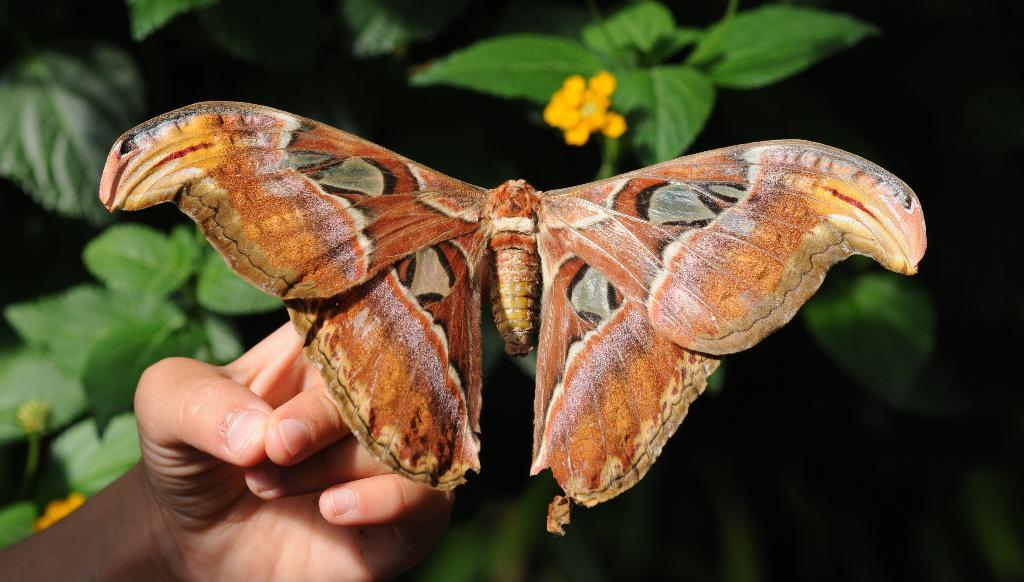What is the main subject of the image? The main subject of the image is a butterfly. Where is the butterfly located in the image? The butterfly is on the hand of a person. What can be seen in the background of the image? There are leaves and flowers in the background of the image. What type of toys can be seen being exchanged between the person and the butterfly in the image? There are no toys present in the image, and the butterfly is not exchanging anything with the person. 